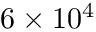<formula> <loc_0><loc_0><loc_500><loc_500>6 \times 1 0 ^ { 4 }</formula> 